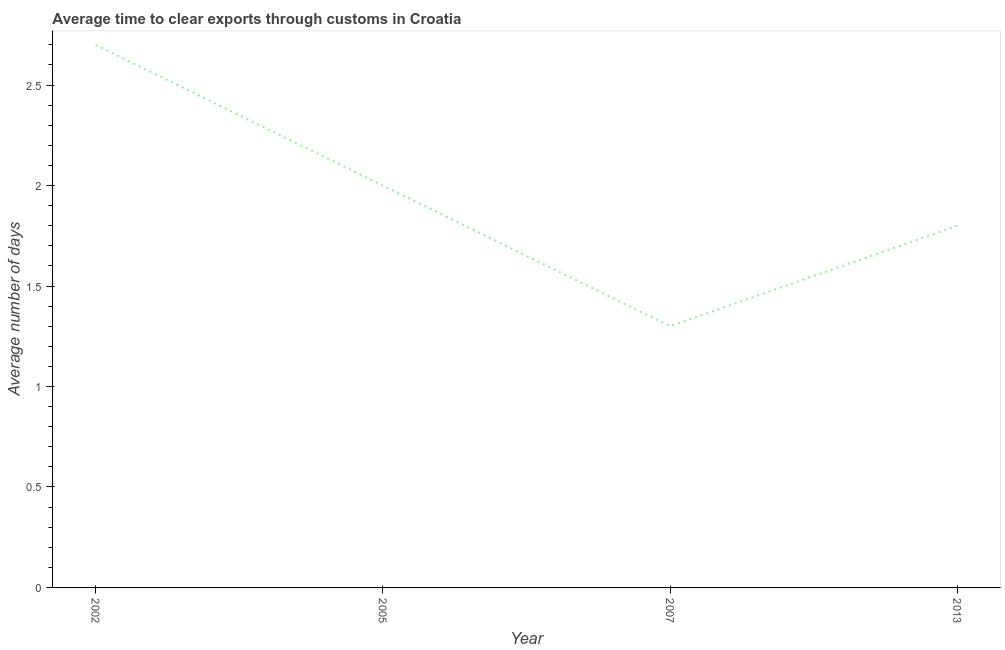What is the difference between the time to clear exports through customs in 2002 and 2007?
Make the answer very short. 1.4. What is the average time to clear exports through customs per year?
Provide a short and direct response. 1.95. What is the median time to clear exports through customs?
Provide a succinct answer. 1.9. In how many years, is the time to clear exports through customs greater than 0.5 days?
Offer a very short reply. 4. What is the ratio of the time to clear exports through customs in 2002 to that in 2007?
Your answer should be compact. 2.08. What is the difference between the highest and the second highest time to clear exports through customs?
Keep it short and to the point. 0.7. What is the difference between the highest and the lowest time to clear exports through customs?
Make the answer very short. 1.4. Does the time to clear exports through customs monotonically increase over the years?
Provide a short and direct response. No. How many lines are there?
Your answer should be very brief. 1. What is the difference between two consecutive major ticks on the Y-axis?
Provide a succinct answer. 0.5. Does the graph contain any zero values?
Offer a terse response. No. What is the title of the graph?
Provide a short and direct response. Average time to clear exports through customs in Croatia. What is the label or title of the X-axis?
Ensure brevity in your answer.  Year. What is the label or title of the Y-axis?
Give a very brief answer. Average number of days. What is the Average number of days of 2002?
Give a very brief answer. 2.7. What is the Average number of days in 2013?
Offer a very short reply. 1.8. What is the difference between the Average number of days in 2002 and 2007?
Keep it short and to the point. 1.4. What is the difference between the Average number of days in 2007 and 2013?
Offer a terse response. -0.5. What is the ratio of the Average number of days in 2002 to that in 2005?
Offer a very short reply. 1.35. What is the ratio of the Average number of days in 2002 to that in 2007?
Ensure brevity in your answer.  2.08. What is the ratio of the Average number of days in 2005 to that in 2007?
Keep it short and to the point. 1.54. What is the ratio of the Average number of days in 2005 to that in 2013?
Provide a succinct answer. 1.11. What is the ratio of the Average number of days in 2007 to that in 2013?
Keep it short and to the point. 0.72. 